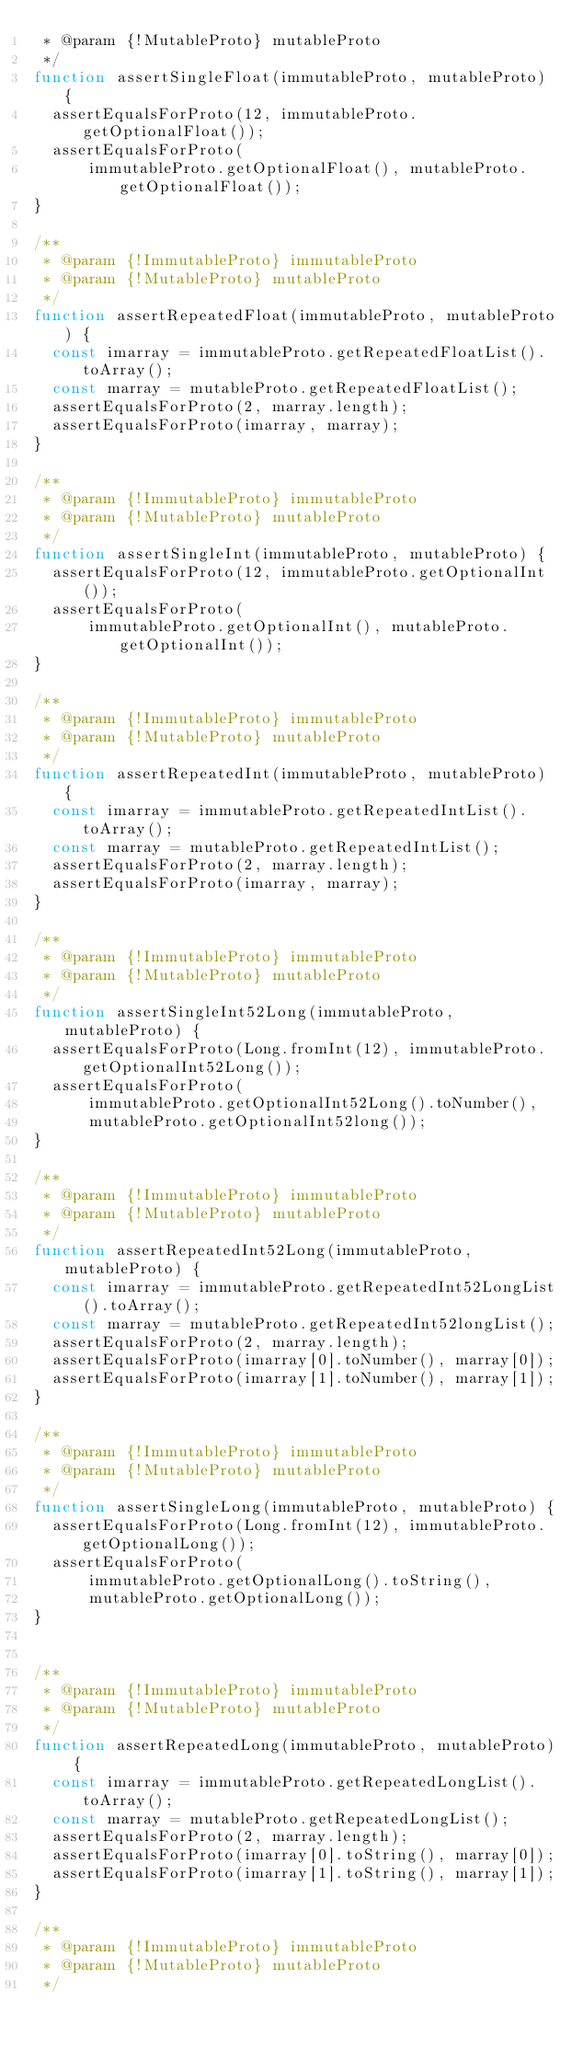<code> <loc_0><loc_0><loc_500><loc_500><_JavaScript_> * @param {!MutableProto} mutableProto
 */
function assertSingleFloat(immutableProto, mutableProto) {
  assertEqualsForProto(12, immutableProto.getOptionalFloat());
  assertEqualsForProto(
      immutableProto.getOptionalFloat(), mutableProto.getOptionalFloat());
}

/**
 * @param {!ImmutableProto} immutableProto
 * @param {!MutableProto} mutableProto
 */
function assertRepeatedFloat(immutableProto, mutableProto) {
  const imarray = immutableProto.getRepeatedFloatList().toArray();
  const marray = mutableProto.getRepeatedFloatList();
  assertEqualsForProto(2, marray.length);
  assertEqualsForProto(imarray, marray);
}

/**
 * @param {!ImmutableProto} immutableProto
 * @param {!MutableProto} mutableProto
 */
function assertSingleInt(immutableProto, mutableProto) {
  assertEqualsForProto(12, immutableProto.getOptionalInt());
  assertEqualsForProto(
      immutableProto.getOptionalInt(), mutableProto.getOptionalInt());
}

/**
 * @param {!ImmutableProto} immutableProto
 * @param {!MutableProto} mutableProto
 */
function assertRepeatedInt(immutableProto, mutableProto) {
  const imarray = immutableProto.getRepeatedIntList().toArray();
  const marray = mutableProto.getRepeatedIntList();
  assertEqualsForProto(2, marray.length);
  assertEqualsForProto(imarray, marray);
}

/**
 * @param {!ImmutableProto} immutableProto
 * @param {!MutableProto} mutableProto
 */
function assertSingleInt52Long(immutableProto, mutableProto) {
  assertEqualsForProto(Long.fromInt(12), immutableProto.getOptionalInt52Long());
  assertEqualsForProto(
      immutableProto.getOptionalInt52Long().toNumber(),
      mutableProto.getOptionalInt52long());
}

/**
 * @param {!ImmutableProto} immutableProto
 * @param {!MutableProto} mutableProto
 */
function assertRepeatedInt52Long(immutableProto, mutableProto) {
  const imarray = immutableProto.getRepeatedInt52LongList().toArray();
  const marray = mutableProto.getRepeatedInt52longList();
  assertEqualsForProto(2, marray.length);
  assertEqualsForProto(imarray[0].toNumber(), marray[0]);
  assertEqualsForProto(imarray[1].toNumber(), marray[1]);
}

/**
 * @param {!ImmutableProto} immutableProto
 * @param {!MutableProto} mutableProto
 */
function assertSingleLong(immutableProto, mutableProto) {
  assertEqualsForProto(Long.fromInt(12), immutableProto.getOptionalLong());
  assertEqualsForProto(
      immutableProto.getOptionalLong().toString(),
      mutableProto.getOptionalLong());
}


/**
 * @param {!ImmutableProto} immutableProto
 * @param {!MutableProto} mutableProto
 */
function assertRepeatedLong(immutableProto, mutableProto) {
  const imarray = immutableProto.getRepeatedLongList().toArray();
  const marray = mutableProto.getRepeatedLongList();
  assertEqualsForProto(2, marray.length);
  assertEqualsForProto(imarray[0].toString(), marray[0]);
  assertEqualsForProto(imarray[1].toString(), marray[1]);
}

/**
 * @param {!ImmutableProto} immutableProto
 * @param {!MutableProto} mutableProto
 */</code> 